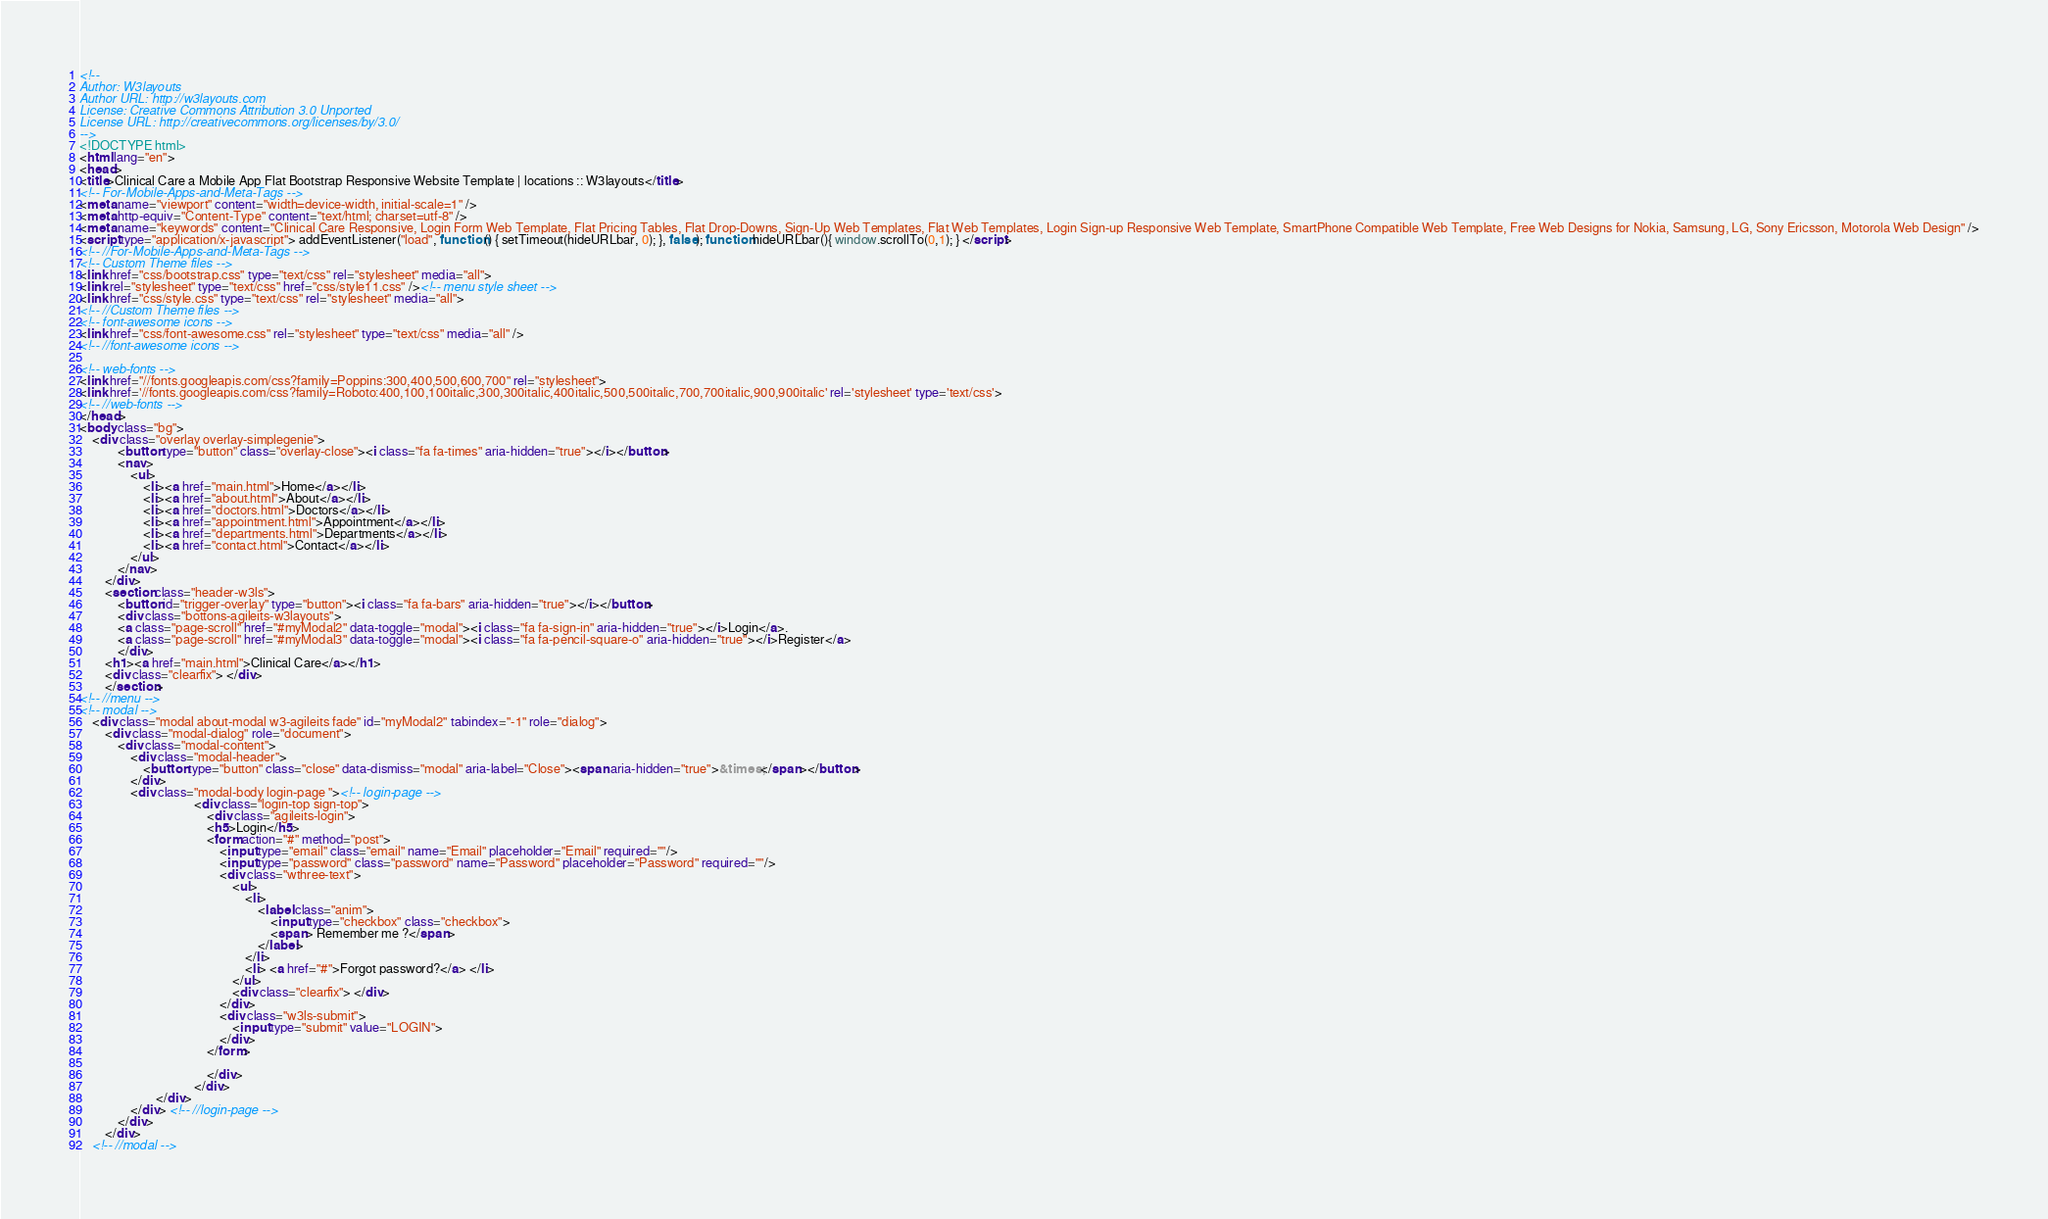Convert code to text. <code><loc_0><loc_0><loc_500><loc_500><_HTML_><!--
Author: W3layouts
Author URL: http://w3layouts.com
License: Creative Commons Attribution 3.0 Unported
License URL: http://creativecommons.org/licenses/by/3.0/
-->
<!DOCTYPE html>
<html lang="en">
<head>
<title>Clinical Care a Mobile App Flat Bootstrap Responsive Website Template | locations :: W3layouts</title> 
<!-- For-Mobile-Apps-and-Meta-Tags -->
<meta name="viewport" content="width=device-width, initial-scale=1" />
<meta http-equiv="Content-Type" content="text/html; charset=utf-8" />
<meta name="keywords" content="Clinical Care Responsive, Login Form Web Template, Flat Pricing Tables, Flat Drop-Downs, Sign-Up Web Templates, Flat Web Templates, Login Sign-up Responsive Web Template, SmartPhone Compatible Web Template, Free Web Designs for Nokia, Samsung, LG, Sony Ericsson, Motorola Web Design" />
<script type="application/x-javascript"> addEventListener("load", function() { setTimeout(hideURLbar, 0); }, false); function hideURLbar(){ window.scrollTo(0,1); } </script>
<!-- //For-Mobile-Apps-and-Meta-Tags -->
<!-- Custom Theme files -->
<link href="css/bootstrap.css" type="text/css" rel="stylesheet" media="all">
<link rel="stylesheet" type="text/css" href="css/style11.css" /><!-- menu style sheet -->
<link href="css/style.css" type="text/css" rel="stylesheet" media="all"> 
<!-- //Custom Theme files -->
<!-- font-awesome icons -->
<link href="css/font-awesome.css" rel="stylesheet" type="text/css" media="all" /> 
<!-- //font-awesome icons -->

<!-- web-fonts -->  
<link href="//fonts.googleapis.com/css?family=Poppins:300,400,500,600,700" rel="stylesheet">
<link href='//fonts.googleapis.com/css?family=Roboto:400,100,100italic,300,300italic,400italic,500,500italic,700,700italic,900,900italic' rel='stylesheet' type='text/css'>
<!-- //web-fonts -->
</head>
<body class="bg">
	<div class="overlay overlay-simplegenie">
			<button type="button" class="overlay-close"><i class="fa fa-times" aria-hidden="true"></i></button>
			<nav>
				<ul>
					<li><a href="main.html">Home</a></li>
					<li><a href="about.html">About</a></li>
					<li><a href="doctors.html">Doctors</a></li>
					<li><a href="appointment.html">Appointment</a></li>
					<li><a href="departments.html">Departments</a></li>
					<li><a href="contact.html">Contact</a></li>
				</ul>
			</nav>
		</div>
		<section class="header-w3ls"> 
			<button id="trigger-overlay" type="button"><i class="fa fa-bars" aria-hidden="true"></i></button>
			<div class="bottons-agileits-w3layouts">
			<a class="page-scroll" href="#myModal2" data-toggle="modal"><i class="fa fa-sign-in" aria-hidden="true"></i>Login</a>.
			<a class="page-scroll" href="#myModal3" data-toggle="modal"><i class="fa fa-pencil-square-o" aria-hidden="true"></i>Register</a>
			</div>
		<h1><a href="main.html">Clinical Care</a></h1>
		<div class="clearfix"> </div>
		</section>
<!-- //menu -->
<!-- modal -->
	<div class="modal about-modal w3-agileits fade" id="myModal2" tabindex="-1" role="dialog">
		<div class="modal-dialog" role="document">
			<div class="modal-content">
				<div class="modal-header">
					<button type="button" class="close" data-dismiss="modal" aria-label="Close"><span aria-hidden="true">&times;</span></button>						
				</div> 
				<div class="modal-body login-page "><!-- login-page -->     
									<div class="login-top sign-top">
										<div class="agileits-login">
										<h5>Login</h5>
										<form action="#" method="post">
											<input type="email" class="email" name="Email" placeholder="Email" required=""/>
											<input type="password" class="password" name="Password" placeholder="Password" required=""/>
											<div class="wthree-text"> 
												<ul> 
													<li>
														<label class="anim">
															<input type="checkbox" class="checkbox">
															<span> Remember me ?</span> 
														</label> 
													</li>
													<li> <a href="#">Forgot password?</a> </li>
												</ul>
												<div class="clearfix"> </div>
											</div>  
											<div class="w3ls-submit"> 
												<input type="submit" value="LOGIN">  	
											</div>	
										</form>

										</div>  
									</div>
						</div>  
				</div> <!-- //login-page -->
			</div>
		</div>
	<!-- //modal --> </code> 